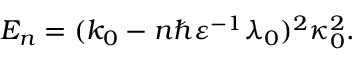Convert formula to latex. <formula><loc_0><loc_0><loc_500><loc_500>E _ { n } = ( k _ { 0 } - n \hbar { \varepsilon } ^ { - 1 } \lambda _ { 0 } ) ^ { 2 } \kappa _ { 0 } ^ { 2 } .</formula> 